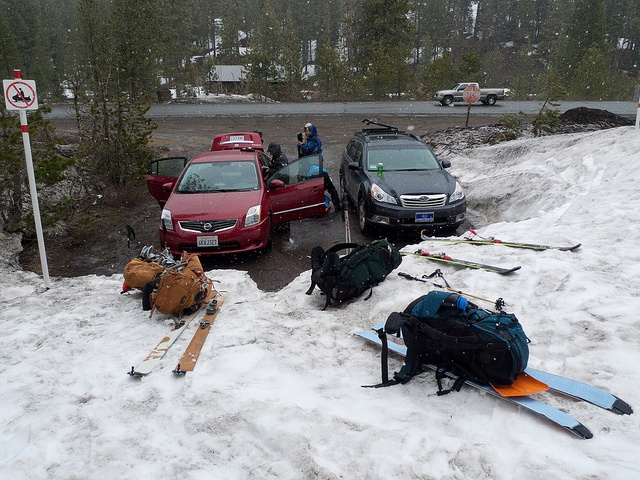Describe the objects in this image and their specific colors. I can see car in darkgreen, black, maroon, brown, and gray tones, car in darkgreen, black, and gray tones, backpack in darkgreen, black, darkblue, blue, and gray tones, skis in darkgreen, lightblue, gray, and lightgray tones, and backpack in darkgreen, black, gray, darkgray, and lightgray tones in this image. 